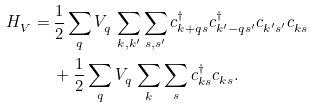<formula> <loc_0><loc_0><loc_500><loc_500>H ^ { \ } _ { V } = & \, \frac { 1 } { 2 } \sum _ { q } V ^ { \ } _ { q } \sum _ { k , k ^ { \prime } } \sum _ { s , s ^ { \prime } } c ^ { \dag } _ { k + q s } c ^ { \dag } _ { k ^ { \prime } - q s ^ { \prime } } c ^ { \ } _ { k ^ { \prime } s ^ { \prime } } c ^ { \ } _ { k s } \\ & \, + \frac { 1 } { 2 } \sum _ { q } V ^ { \ } _ { q } \sum _ { k } \sum _ { s } c ^ { \dag } _ { k s } c ^ { \ } _ { k s } .</formula> 